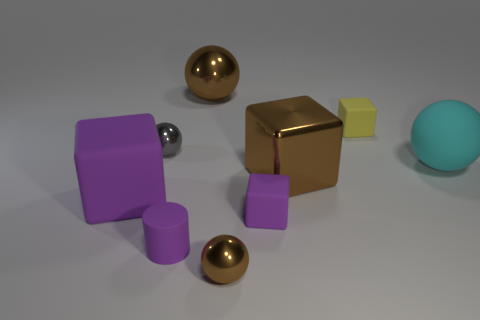Subtract all red spheres. Subtract all gray cylinders. How many spheres are left? 4 Add 1 small things. How many objects exist? 10 Subtract all cylinders. How many objects are left? 8 Subtract 0 gray cubes. How many objects are left? 9 Subtract all large cyan metallic things. Subtract all tiny cubes. How many objects are left? 7 Add 3 shiny blocks. How many shiny blocks are left? 4 Add 8 green spheres. How many green spheres exist? 8 